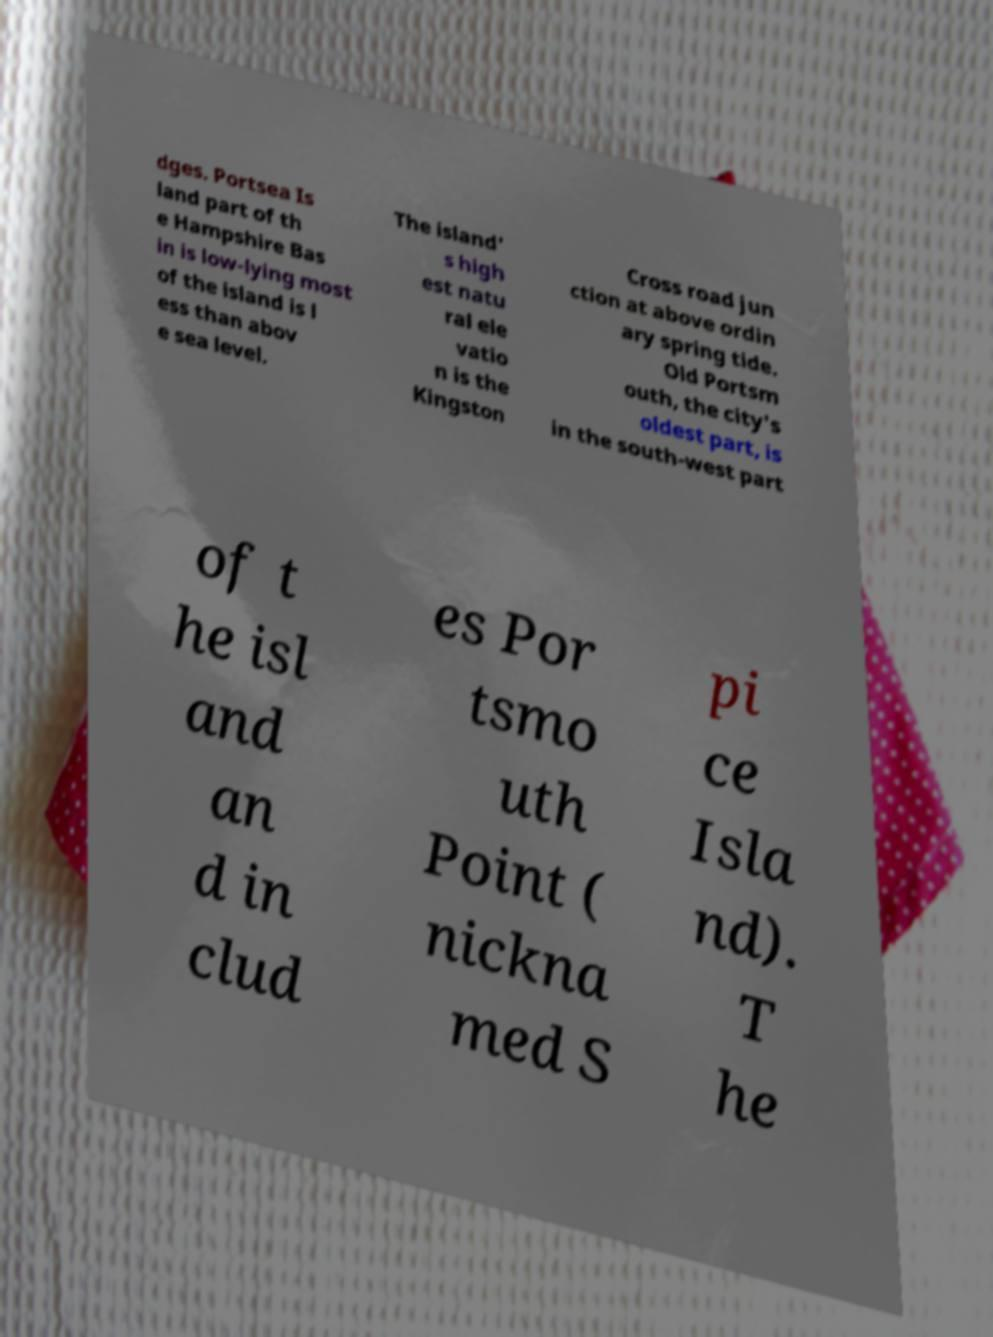Can you read and provide the text displayed in the image?This photo seems to have some interesting text. Can you extract and type it out for me? dges. Portsea Is land part of th e Hampshire Bas in is low-lying most of the island is l ess than abov e sea level. The island' s high est natu ral ele vatio n is the Kingston Cross road jun ction at above ordin ary spring tide. Old Portsm outh, the city's oldest part, is in the south-west part of t he isl and an d in clud es Por tsmo uth Point ( nickna med S pi ce Isla nd). T he 